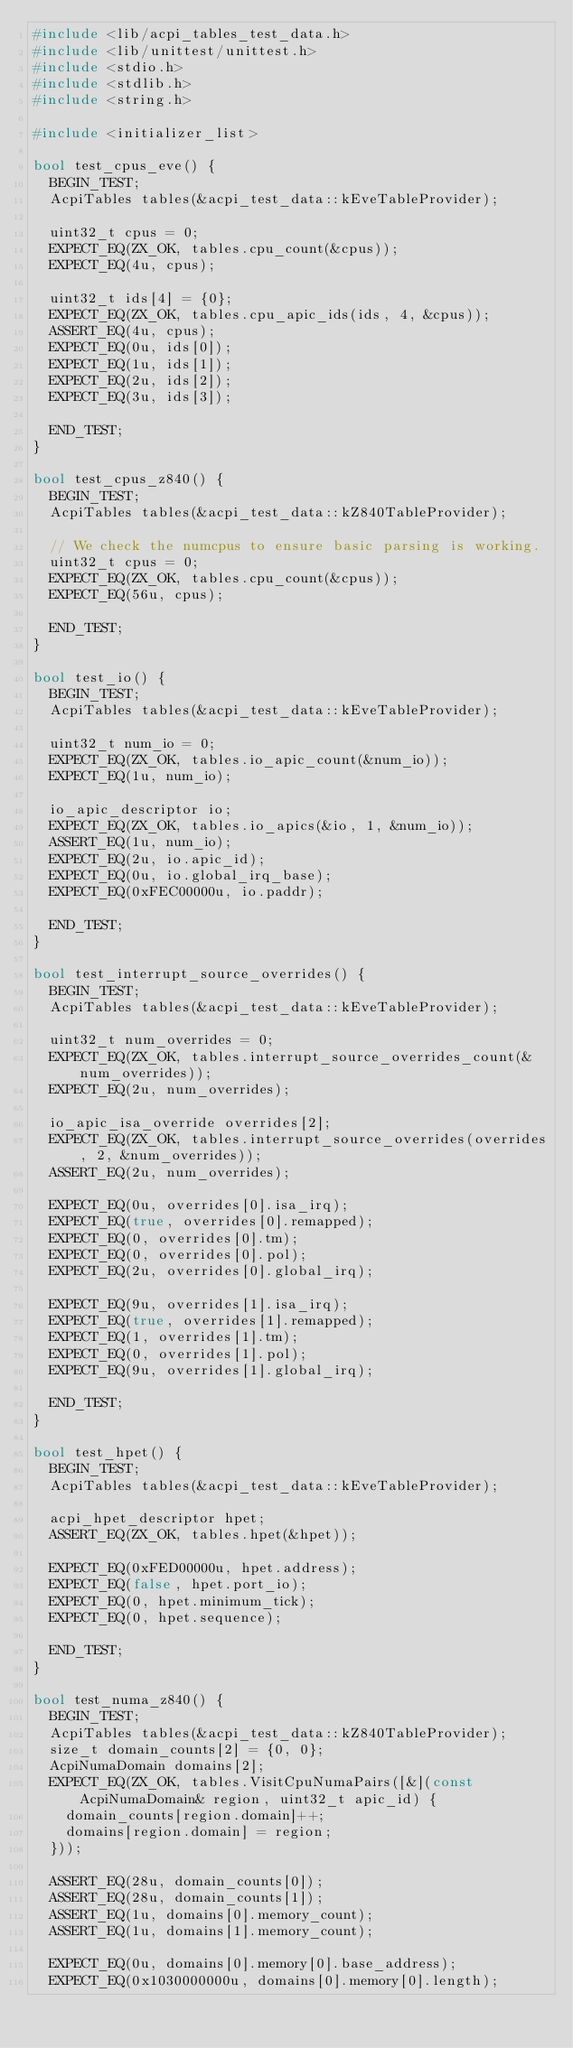<code> <loc_0><loc_0><loc_500><loc_500><_C++_>#include <lib/acpi_tables_test_data.h>
#include <lib/unittest/unittest.h>
#include <stdio.h>
#include <stdlib.h>
#include <string.h>

#include <initializer_list>

bool test_cpus_eve() {
  BEGIN_TEST;
  AcpiTables tables(&acpi_test_data::kEveTableProvider);

  uint32_t cpus = 0;
  EXPECT_EQ(ZX_OK, tables.cpu_count(&cpus));
  EXPECT_EQ(4u, cpus);

  uint32_t ids[4] = {0};
  EXPECT_EQ(ZX_OK, tables.cpu_apic_ids(ids, 4, &cpus));
  ASSERT_EQ(4u, cpus);
  EXPECT_EQ(0u, ids[0]);
  EXPECT_EQ(1u, ids[1]);
  EXPECT_EQ(2u, ids[2]);
  EXPECT_EQ(3u, ids[3]);

  END_TEST;
}

bool test_cpus_z840() {
  BEGIN_TEST;
  AcpiTables tables(&acpi_test_data::kZ840TableProvider);

  // We check the numcpus to ensure basic parsing is working.
  uint32_t cpus = 0;
  EXPECT_EQ(ZX_OK, tables.cpu_count(&cpus));
  EXPECT_EQ(56u, cpus);

  END_TEST;
}

bool test_io() {
  BEGIN_TEST;
  AcpiTables tables(&acpi_test_data::kEveTableProvider);

  uint32_t num_io = 0;
  EXPECT_EQ(ZX_OK, tables.io_apic_count(&num_io));
  EXPECT_EQ(1u, num_io);

  io_apic_descriptor io;
  EXPECT_EQ(ZX_OK, tables.io_apics(&io, 1, &num_io));
  ASSERT_EQ(1u, num_io);
  EXPECT_EQ(2u, io.apic_id);
  EXPECT_EQ(0u, io.global_irq_base);
  EXPECT_EQ(0xFEC00000u, io.paddr);

  END_TEST;
}

bool test_interrupt_source_overrides() {
  BEGIN_TEST;
  AcpiTables tables(&acpi_test_data::kEveTableProvider);

  uint32_t num_overrides = 0;
  EXPECT_EQ(ZX_OK, tables.interrupt_source_overrides_count(&num_overrides));
  EXPECT_EQ(2u, num_overrides);

  io_apic_isa_override overrides[2];
  EXPECT_EQ(ZX_OK, tables.interrupt_source_overrides(overrides, 2, &num_overrides));
  ASSERT_EQ(2u, num_overrides);

  EXPECT_EQ(0u, overrides[0].isa_irq);
  EXPECT_EQ(true, overrides[0].remapped);
  EXPECT_EQ(0, overrides[0].tm);
  EXPECT_EQ(0, overrides[0].pol);
  EXPECT_EQ(2u, overrides[0].global_irq);

  EXPECT_EQ(9u, overrides[1].isa_irq);
  EXPECT_EQ(true, overrides[1].remapped);
  EXPECT_EQ(1, overrides[1].tm);
  EXPECT_EQ(0, overrides[1].pol);
  EXPECT_EQ(9u, overrides[1].global_irq);

  END_TEST;
}

bool test_hpet() {
  BEGIN_TEST;
  AcpiTables tables(&acpi_test_data::kEveTableProvider);

  acpi_hpet_descriptor hpet;
  ASSERT_EQ(ZX_OK, tables.hpet(&hpet));

  EXPECT_EQ(0xFED00000u, hpet.address);
  EXPECT_EQ(false, hpet.port_io);
  EXPECT_EQ(0, hpet.minimum_tick);
  EXPECT_EQ(0, hpet.sequence);

  END_TEST;
}

bool test_numa_z840() {
  BEGIN_TEST;
  AcpiTables tables(&acpi_test_data::kZ840TableProvider);
  size_t domain_counts[2] = {0, 0};
  AcpiNumaDomain domains[2];
  EXPECT_EQ(ZX_OK, tables.VisitCpuNumaPairs([&](const AcpiNumaDomain& region, uint32_t apic_id) {
    domain_counts[region.domain]++;
    domains[region.domain] = region;
  }));

  ASSERT_EQ(28u, domain_counts[0]);
  ASSERT_EQ(28u, domain_counts[1]);
  ASSERT_EQ(1u, domains[0].memory_count);
  ASSERT_EQ(1u, domains[1].memory_count);

  EXPECT_EQ(0u, domains[0].memory[0].base_address);
  EXPECT_EQ(0x1030000000u, domains[0].memory[0].length);
</code> 